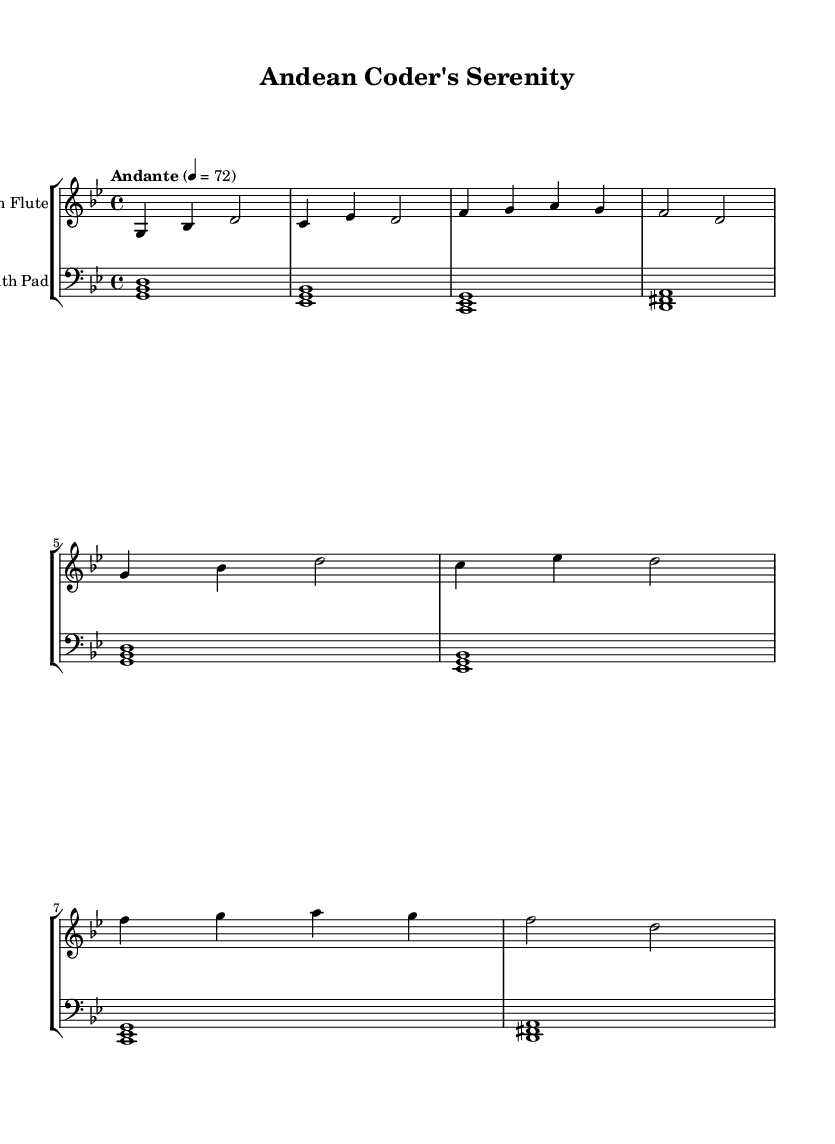What is the key signature of this music? The key signature is G minor, which contains two flats (B flat and E flat). This can be determined by examining the key signature icon at the beginning of the staff, which indicates G minor.
Answer: G minor What is the time signature of this music? The time signature is 4/4, indicating four beats in a measure, with a quarter note receiving one beat. This can be found in the upper left corner of the sheet music, represented by the numbers in the time signature notation.
Answer: 4/4 What is the tempo marking for this piece? The tempo marking is Andante at a speed of 72 beats per minute. This is indicated under the header section and shows the intended rate of speed at which the piece should be played.
Answer: Andante 4 = 72 How many measures are there in the Andean flute part? The flute part consists of 8 measures in total, which can be counted by identifying the vertical lines that separate the measures in the music.
Answer: 8 Identify the two instruments used in this piece. The instruments used are the Andean flute and a synth pad. This can be inferred from the instrument names specified at the beginning of each staff.
Answer: Andean flute, synth pad Which note appears most frequently in the synth pad part? The note G appears most frequently, which can be deduced by reviewing the bass staff for occurrences of G, taking note of how many times it is played within the measured sections.
Answer: G How does the structure of the melodies reflect traditional Andean music characteristics? The melodic line features pentatonic scale elements and long, flowing notes typical of traditional Andean flute music, which can be recognized by the use of specific intervals and the overall melodic contour in the Andean flute part.
Answer: Pentatonic scale, flowing 